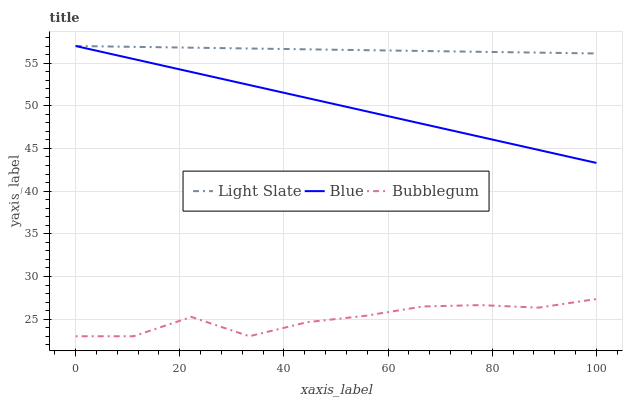Does Bubblegum have the minimum area under the curve?
Answer yes or no. Yes. Does Light Slate have the maximum area under the curve?
Answer yes or no. Yes. Does Blue have the minimum area under the curve?
Answer yes or no. No. Does Blue have the maximum area under the curve?
Answer yes or no. No. Is Blue the smoothest?
Answer yes or no. Yes. Is Bubblegum the roughest?
Answer yes or no. Yes. Is Bubblegum the smoothest?
Answer yes or no. No. Is Blue the roughest?
Answer yes or no. No. Does Bubblegum have the lowest value?
Answer yes or no. Yes. Does Blue have the lowest value?
Answer yes or no. No. Does Blue have the highest value?
Answer yes or no. Yes. Does Bubblegum have the highest value?
Answer yes or no. No. Is Bubblegum less than Light Slate?
Answer yes or no. Yes. Is Light Slate greater than Bubblegum?
Answer yes or no. Yes. Does Light Slate intersect Blue?
Answer yes or no. Yes. Is Light Slate less than Blue?
Answer yes or no. No. Is Light Slate greater than Blue?
Answer yes or no. No. Does Bubblegum intersect Light Slate?
Answer yes or no. No. 